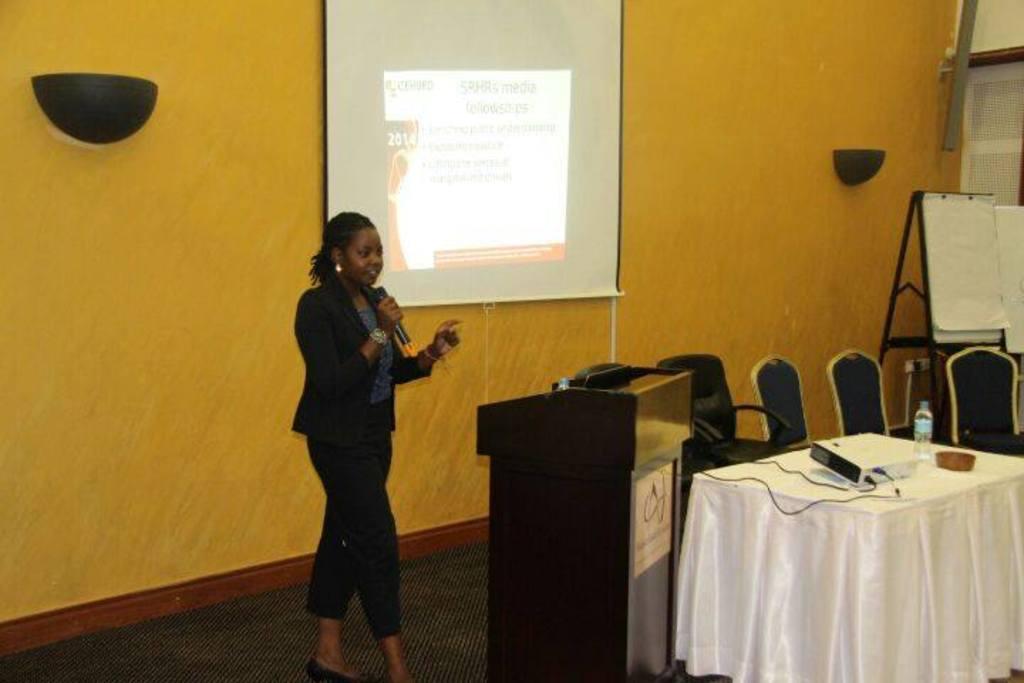Please provide a concise description of this image. As we can see in the image there is a yellow color wall, screen, table, chairs, board and a woman holding mic. 